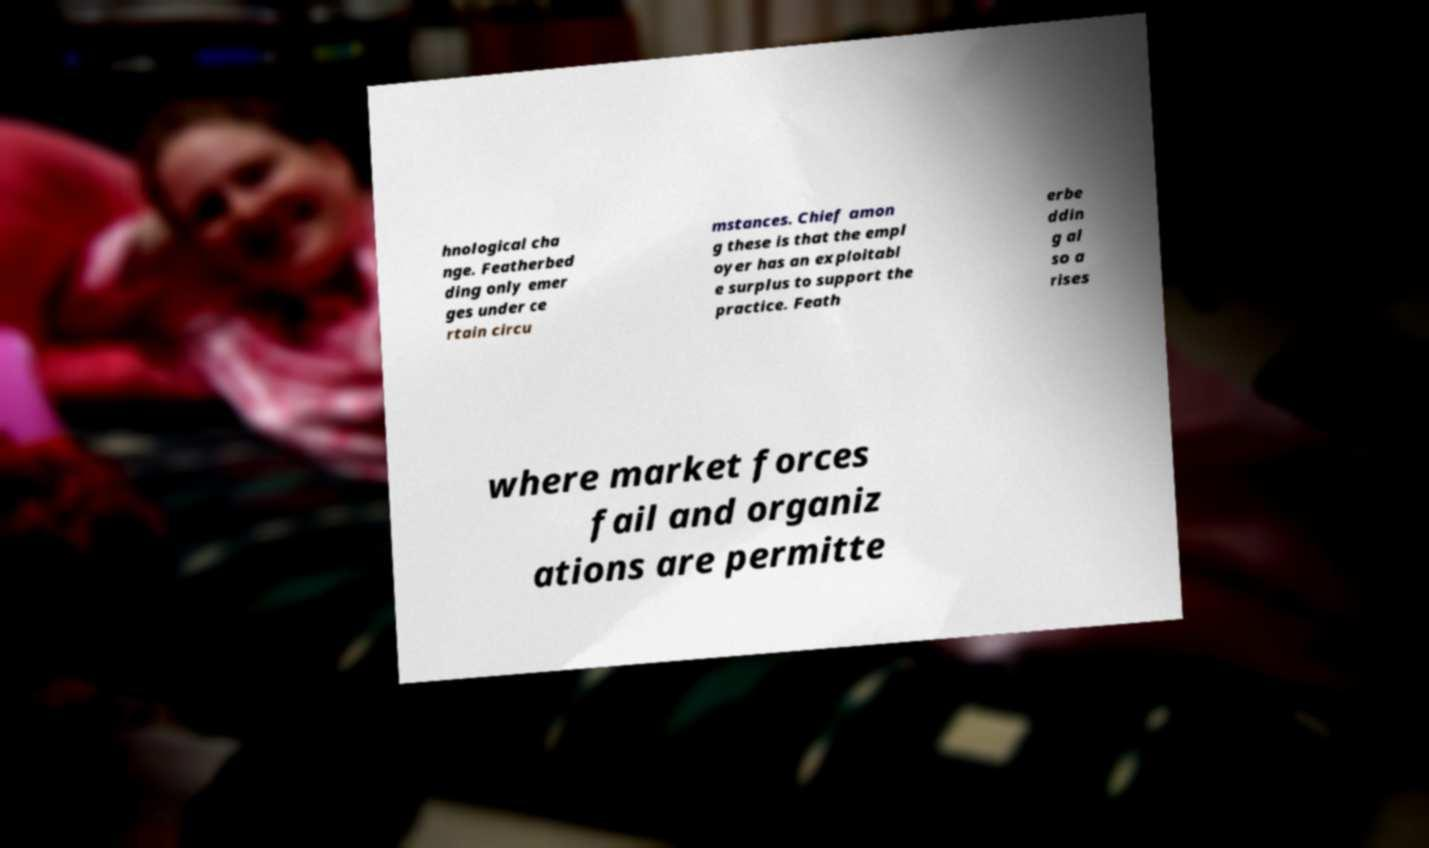Please read and relay the text visible in this image. What does it say? hnological cha nge. Featherbed ding only emer ges under ce rtain circu mstances. Chief amon g these is that the empl oyer has an exploitabl e surplus to support the practice. Feath erbe ddin g al so a rises where market forces fail and organiz ations are permitte 